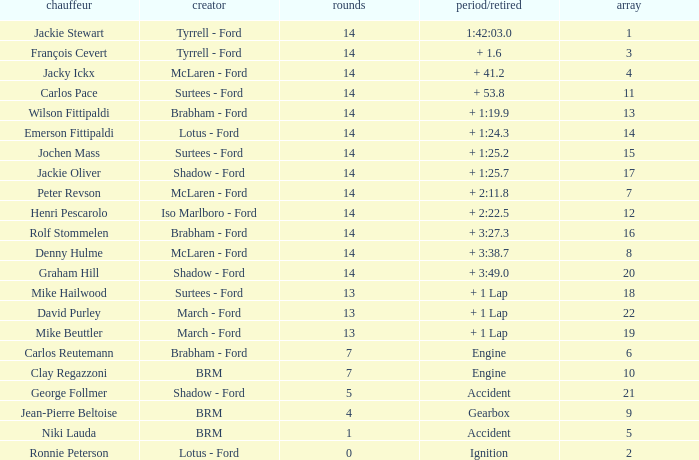What is the low lap total for a grid larger than 16 and has a Time/Retired of + 3:27.3? None. 